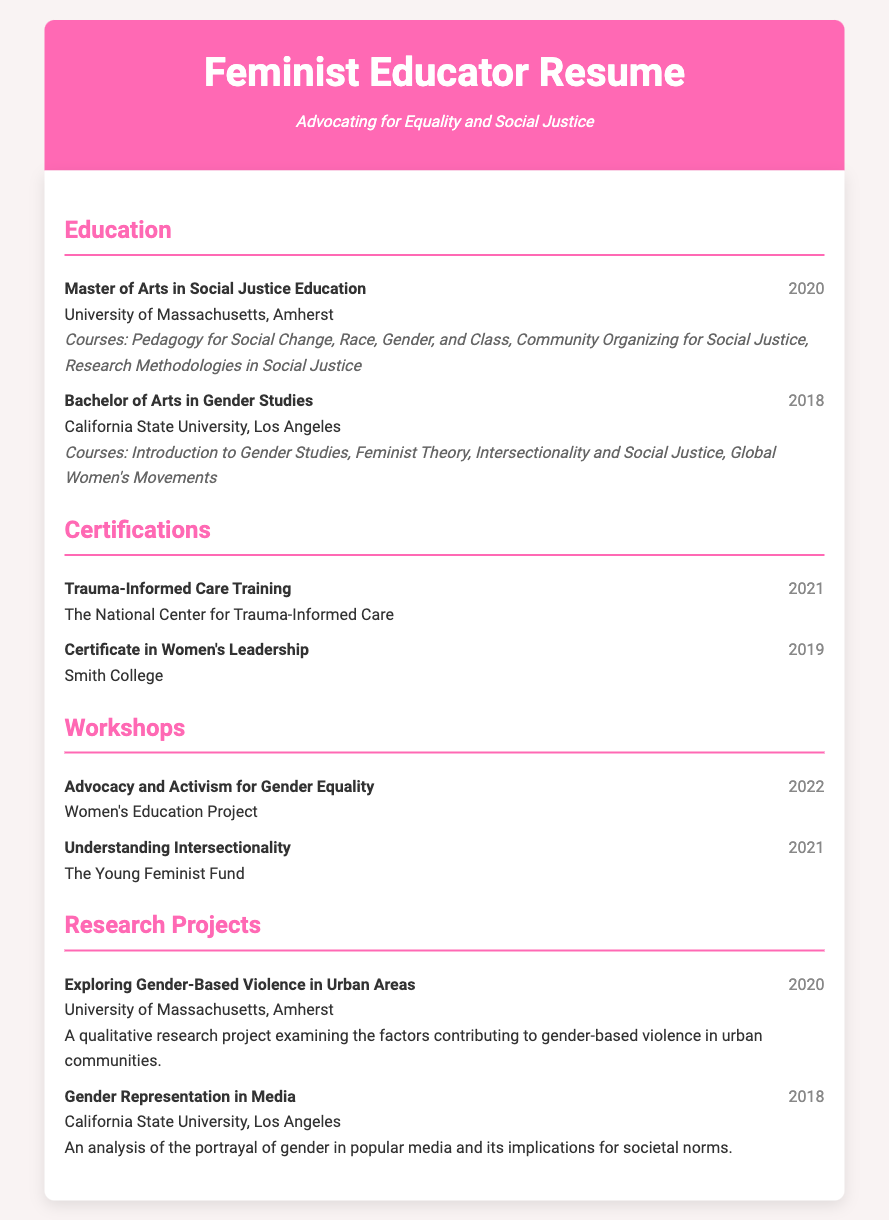What degree was earned in 2020? The document states that a Master of Arts in Social Justice Education was earned in 2020 at the University of Massachusetts, Amherst.
Answer: Master of Arts in Social Justice Education What certification was obtained in 2019? According to the resume, the Certificate in Women's Leadership was obtained in 2019.
Answer: Certificate in Women's Leadership Which university awarded the Bachelor of Arts in Gender Studies? The resume specifies that the Bachelor of Arts in Gender Studies was awarded by California State University, Los Angeles.
Answer: California State University, Los Angeles In which year was the workshop on Understanding Intersectionality conducted? The resume notes that the workshop on Understanding Intersectionality took place in 2021.
Answer: 2021 What is the focus of the research project conducted in 2020? The document describes a qualitative research project exploring gender-based violence in urban areas, indicating its focus of study.
Answer: Gender-Based Violence in Urban Areas How many courses were listed under the Master's degree? The resume lists four courses under the Master of Arts in Social Justice Education.
Answer: Four What is one of the themes covered in the Bachelor of Arts in Gender Studies? The resume includes Feminist Theory as one of the courses under the Bachelor of Arts in Gender Studies, reflecting its themes.
Answer: Feminist Theory Which organization conducted the Trauma-Informed Care Training? The resume specifies that the Trauma-Informed Care Training was conducted by The National Center for Trauma-Informed Care.
Answer: The National Center for Trauma-Informed Care 